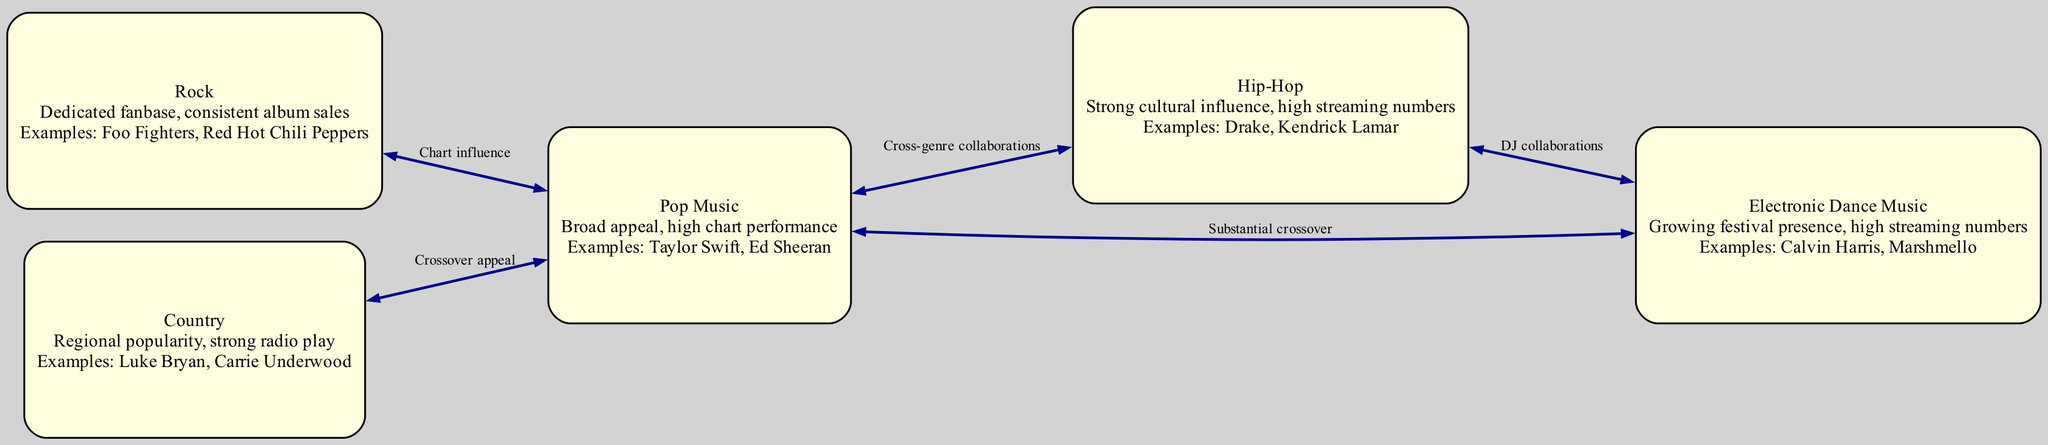What is the total number of music genres represented in the diagram? By counting the nodes listed in the diagram, we find five distinct music genres: Pop, Hip-Hop, Rock, Country, and Electronic Dance Music. Therefore, the total count is 5.
Answer: 5 Which genre is described as having "high chart performance"? The information can be found in the description of the Pop Music node, where it mentions "broad appeal, high chart performance." Hence, the genre is Pop Music.
Answer: Pop Music What is the relationship between Pop Music and Country? The diagram indicates a "Crossover appeal" edge connecting Pop Music to Country, meaning these two genres share influences or audiences.
Answer: Crossover appeal Who are the example artists for Electronic Dance Music? Looking at the EDM node, the example artists provided are "Calvin Harris, Marshmello," which directly answer the question about who represents this genre.
Answer: Calvin Harris, Marshmello What type of collaborations exist between Hip-Hop and EDM? The diagram specifies that there is a "DJ collaborations" label on the edge connecting Hip-Hop and Electronic Dance Music, indicating the nature of their interaction.
Answer: DJ collaborations How does Rock influence Pop? The relationship described in the diagram illustrates that Rock has a "Chart influence" on Pop, suggesting that Rock music contributes significantly to Pop's chart standings.
Answer: Chart influence How many edges connect Pop Music to other genres? By analyzing the edges, we notice that Pop Music has connections to Hip-Hop, EDM, Country, and Rock – a total of four edges.
Answer: 4 What genre is characterized by a "dedicated fanbase"? The description for the Rock Music node states it has a "dedicated fanbase," clearly identifying Rock as the genre with this characteristic.
Answer: Rock What does the diagram suggest about the impact of Electronic Dance Music on the market? The description under EDM indicates a "growing festival presence" and "high streaming numbers," suggesting that EDM is becoming more influential in the music market.
Answer: Growing festival presence, high streaming numbers 